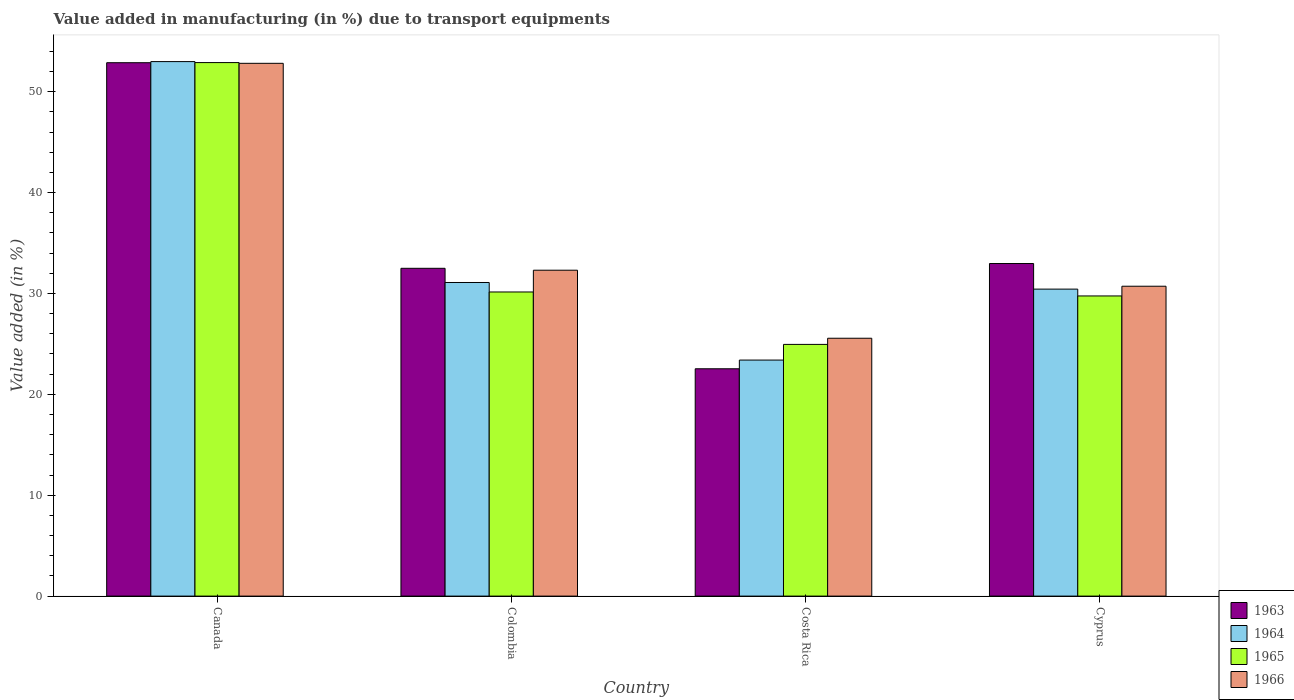How many different coloured bars are there?
Make the answer very short. 4. Are the number of bars on each tick of the X-axis equal?
Provide a succinct answer. Yes. What is the percentage of value added in manufacturing due to transport equipments in 1963 in Canada?
Give a very brief answer. 52.87. Across all countries, what is the maximum percentage of value added in manufacturing due to transport equipments in 1963?
Make the answer very short. 52.87. Across all countries, what is the minimum percentage of value added in manufacturing due to transport equipments in 1964?
Offer a very short reply. 23.4. In which country was the percentage of value added in manufacturing due to transport equipments in 1963 maximum?
Offer a terse response. Canada. In which country was the percentage of value added in manufacturing due to transport equipments in 1965 minimum?
Keep it short and to the point. Costa Rica. What is the total percentage of value added in manufacturing due to transport equipments in 1966 in the graph?
Offer a terse response. 141.39. What is the difference between the percentage of value added in manufacturing due to transport equipments in 1963 in Canada and that in Costa Rica?
Offer a terse response. 30.34. What is the difference between the percentage of value added in manufacturing due to transport equipments in 1964 in Cyprus and the percentage of value added in manufacturing due to transport equipments in 1963 in Canada?
Make the answer very short. -22.44. What is the average percentage of value added in manufacturing due to transport equipments in 1965 per country?
Offer a terse response. 34.43. What is the difference between the percentage of value added in manufacturing due to transport equipments of/in 1964 and percentage of value added in manufacturing due to transport equipments of/in 1966 in Cyprus?
Ensure brevity in your answer.  -0.29. What is the ratio of the percentage of value added in manufacturing due to transport equipments in 1963 in Colombia to that in Costa Rica?
Your answer should be very brief. 1.44. Is the percentage of value added in manufacturing due to transport equipments in 1966 in Canada less than that in Colombia?
Make the answer very short. No. Is the difference between the percentage of value added in manufacturing due to transport equipments in 1964 in Canada and Costa Rica greater than the difference between the percentage of value added in manufacturing due to transport equipments in 1966 in Canada and Costa Rica?
Give a very brief answer. Yes. What is the difference between the highest and the second highest percentage of value added in manufacturing due to transport equipments in 1966?
Keep it short and to the point. -20.51. What is the difference between the highest and the lowest percentage of value added in manufacturing due to transport equipments in 1964?
Give a very brief answer. 29.59. Is the sum of the percentage of value added in manufacturing due to transport equipments in 1963 in Canada and Costa Rica greater than the maximum percentage of value added in manufacturing due to transport equipments in 1964 across all countries?
Ensure brevity in your answer.  Yes. Is it the case that in every country, the sum of the percentage of value added in manufacturing due to transport equipments in 1963 and percentage of value added in manufacturing due to transport equipments in 1965 is greater than the sum of percentage of value added in manufacturing due to transport equipments in 1966 and percentage of value added in manufacturing due to transport equipments in 1964?
Your answer should be compact. No. What does the 2nd bar from the left in Canada represents?
Your response must be concise. 1964. What does the 1st bar from the right in Cyprus represents?
Offer a terse response. 1966. Are all the bars in the graph horizontal?
Give a very brief answer. No. What is the difference between two consecutive major ticks on the Y-axis?
Ensure brevity in your answer.  10. Are the values on the major ticks of Y-axis written in scientific E-notation?
Provide a succinct answer. No. Does the graph contain grids?
Provide a short and direct response. No. What is the title of the graph?
Your response must be concise. Value added in manufacturing (in %) due to transport equipments. What is the label or title of the Y-axis?
Offer a terse response. Value added (in %). What is the Value added (in %) of 1963 in Canada?
Provide a succinct answer. 52.87. What is the Value added (in %) of 1964 in Canada?
Ensure brevity in your answer.  52.98. What is the Value added (in %) of 1965 in Canada?
Your answer should be compact. 52.89. What is the Value added (in %) in 1966 in Canada?
Your response must be concise. 52.81. What is the Value added (in %) in 1963 in Colombia?
Provide a succinct answer. 32.49. What is the Value added (in %) of 1964 in Colombia?
Your answer should be compact. 31.09. What is the Value added (in %) in 1965 in Colombia?
Ensure brevity in your answer.  30.15. What is the Value added (in %) in 1966 in Colombia?
Your response must be concise. 32.3. What is the Value added (in %) of 1963 in Costa Rica?
Your response must be concise. 22.53. What is the Value added (in %) of 1964 in Costa Rica?
Your response must be concise. 23.4. What is the Value added (in %) of 1965 in Costa Rica?
Provide a short and direct response. 24.95. What is the Value added (in %) in 1966 in Costa Rica?
Your answer should be very brief. 25.56. What is the Value added (in %) in 1963 in Cyprus?
Your answer should be compact. 32.97. What is the Value added (in %) in 1964 in Cyprus?
Your answer should be very brief. 30.43. What is the Value added (in %) in 1965 in Cyprus?
Provide a succinct answer. 29.75. What is the Value added (in %) of 1966 in Cyprus?
Your response must be concise. 30.72. Across all countries, what is the maximum Value added (in %) of 1963?
Your answer should be compact. 52.87. Across all countries, what is the maximum Value added (in %) of 1964?
Offer a terse response. 52.98. Across all countries, what is the maximum Value added (in %) in 1965?
Your answer should be very brief. 52.89. Across all countries, what is the maximum Value added (in %) of 1966?
Your answer should be compact. 52.81. Across all countries, what is the minimum Value added (in %) in 1963?
Ensure brevity in your answer.  22.53. Across all countries, what is the minimum Value added (in %) in 1964?
Keep it short and to the point. 23.4. Across all countries, what is the minimum Value added (in %) in 1965?
Your answer should be compact. 24.95. Across all countries, what is the minimum Value added (in %) in 1966?
Ensure brevity in your answer.  25.56. What is the total Value added (in %) in 1963 in the graph?
Keep it short and to the point. 140.87. What is the total Value added (in %) in 1964 in the graph?
Make the answer very short. 137.89. What is the total Value added (in %) in 1965 in the graph?
Provide a succinct answer. 137.73. What is the total Value added (in %) of 1966 in the graph?
Offer a terse response. 141.39. What is the difference between the Value added (in %) of 1963 in Canada and that in Colombia?
Offer a very short reply. 20.38. What is the difference between the Value added (in %) in 1964 in Canada and that in Colombia?
Your answer should be very brief. 21.9. What is the difference between the Value added (in %) in 1965 in Canada and that in Colombia?
Offer a terse response. 22.74. What is the difference between the Value added (in %) of 1966 in Canada and that in Colombia?
Your answer should be compact. 20.51. What is the difference between the Value added (in %) in 1963 in Canada and that in Costa Rica?
Keep it short and to the point. 30.34. What is the difference between the Value added (in %) in 1964 in Canada and that in Costa Rica?
Provide a succinct answer. 29.59. What is the difference between the Value added (in %) in 1965 in Canada and that in Costa Rica?
Offer a very short reply. 27.93. What is the difference between the Value added (in %) of 1966 in Canada and that in Costa Rica?
Your response must be concise. 27.25. What is the difference between the Value added (in %) of 1963 in Canada and that in Cyprus?
Make the answer very short. 19.91. What is the difference between the Value added (in %) of 1964 in Canada and that in Cyprus?
Offer a very short reply. 22.55. What is the difference between the Value added (in %) of 1965 in Canada and that in Cyprus?
Ensure brevity in your answer.  23.13. What is the difference between the Value added (in %) in 1966 in Canada and that in Cyprus?
Keep it short and to the point. 22.1. What is the difference between the Value added (in %) in 1963 in Colombia and that in Costa Rica?
Keep it short and to the point. 9.96. What is the difference between the Value added (in %) in 1964 in Colombia and that in Costa Rica?
Provide a short and direct response. 7.69. What is the difference between the Value added (in %) in 1965 in Colombia and that in Costa Rica?
Offer a terse response. 5.2. What is the difference between the Value added (in %) of 1966 in Colombia and that in Costa Rica?
Your response must be concise. 6.74. What is the difference between the Value added (in %) in 1963 in Colombia and that in Cyprus?
Your answer should be very brief. -0.47. What is the difference between the Value added (in %) in 1964 in Colombia and that in Cyprus?
Your answer should be very brief. 0.66. What is the difference between the Value added (in %) of 1965 in Colombia and that in Cyprus?
Offer a very short reply. 0.39. What is the difference between the Value added (in %) of 1966 in Colombia and that in Cyprus?
Your answer should be compact. 1.59. What is the difference between the Value added (in %) of 1963 in Costa Rica and that in Cyprus?
Ensure brevity in your answer.  -10.43. What is the difference between the Value added (in %) in 1964 in Costa Rica and that in Cyprus?
Provide a short and direct response. -7.03. What is the difference between the Value added (in %) in 1965 in Costa Rica and that in Cyprus?
Keep it short and to the point. -4.8. What is the difference between the Value added (in %) of 1966 in Costa Rica and that in Cyprus?
Keep it short and to the point. -5.16. What is the difference between the Value added (in %) of 1963 in Canada and the Value added (in %) of 1964 in Colombia?
Your response must be concise. 21.79. What is the difference between the Value added (in %) in 1963 in Canada and the Value added (in %) in 1965 in Colombia?
Your response must be concise. 22.73. What is the difference between the Value added (in %) of 1963 in Canada and the Value added (in %) of 1966 in Colombia?
Provide a succinct answer. 20.57. What is the difference between the Value added (in %) of 1964 in Canada and the Value added (in %) of 1965 in Colombia?
Provide a short and direct response. 22.84. What is the difference between the Value added (in %) of 1964 in Canada and the Value added (in %) of 1966 in Colombia?
Give a very brief answer. 20.68. What is the difference between the Value added (in %) in 1965 in Canada and the Value added (in %) in 1966 in Colombia?
Keep it short and to the point. 20.58. What is the difference between the Value added (in %) of 1963 in Canada and the Value added (in %) of 1964 in Costa Rica?
Your response must be concise. 29.48. What is the difference between the Value added (in %) in 1963 in Canada and the Value added (in %) in 1965 in Costa Rica?
Provide a succinct answer. 27.92. What is the difference between the Value added (in %) of 1963 in Canada and the Value added (in %) of 1966 in Costa Rica?
Provide a short and direct response. 27.31. What is the difference between the Value added (in %) in 1964 in Canada and the Value added (in %) in 1965 in Costa Rica?
Provide a short and direct response. 28.03. What is the difference between the Value added (in %) of 1964 in Canada and the Value added (in %) of 1966 in Costa Rica?
Provide a succinct answer. 27.42. What is the difference between the Value added (in %) in 1965 in Canada and the Value added (in %) in 1966 in Costa Rica?
Provide a succinct answer. 27.33. What is the difference between the Value added (in %) of 1963 in Canada and the Value added (in %) of 1964 in Cyprus?
Make the answer very short. 22.44. What is the difference between the Value added (in %) in 1963 in Canada and the Value added (in %) in 1965 in Cyprus?
Your answer should be compact. 23.12. What is the difference between the Value added (in %) in 1963 in Canada and the Value added (in %) in 1966 in Cyprus?
Provide a short and direct response. 22.16. What is the difference between the Value added (in %) of 1964 in Canada and the Value added (in %) of 1965 in Cyprus?
Provide a short and direct response. 23.23. What is the difference between the Value added (in %) in 1964 in Canada and the Value added (in %) in 1966 in Cyprus?
Offer a terse response. 22.27. What is the difference between the Value added (in %) of 1965 in Canada and the Value added (in %) of 1966 in Cyprus?
Make the answer very short. 22.17. What is the difference between the Value added (in %) in 1963 in Colombia and the Value added (in %) in 1964 in Costa Rica?
Provide a short and direct response. 9.1. What is the difference between the Value added (in %) in 1963 in Colombia and the Value added (in %) in 1965 in Costa Rica?
Make the answer very short. 7.54. What is the difference between the Value added (in %) in 1963 in Colombia and the Value added (in %) in 1966 in Costa Rica?
Your answer should be very brief. 6.93. What is the difference between the Value added (in %) in 1964 in Colombia and the Value added (in %) in 1965 in Costa Rica?
Offer a terse response. 6.14. What is the difference between the Value added (in %) in 1964 in Colombia and the Value added (in %) in 1966 in Costa Rica?
Offer a very short reply. 5.53. What is the difference between the Value added (in %) in 1965 in Colombia and the Value added (in %) in 1966 in Costa Rica?
Keep it short and to the point. 4.59. What is the difference between the Value added (in %) in 1963 in Colombia and the Value added (in %) in 1964 in Cyprus?
Offer a very short reply. 2.06. What is the difference between the Value added (in %) of 1963 in Colombia and the Value added (in %) of 1965 in Cyprus?
Offer a very short reply. 2.74. What is the difference between the Value added (in %) of 1963 in Colombia and the Value added (in %) of 1966 in Cyprus?
Provide a short and direct response. 1.78. What is the difference between the Value added (in %) of 1964 in Colombia and the Value added (in %) of 1965 in Cyprus?
Offer a terse response. 1.33. What is the difference between the Value added (in %) in 1964 in Colombia and the Value added (in %) in 1966 in Cyprus?
Offer a terse response. 0.37. What is the difference between the Value added (in %) of 1965 in Colombia and the Value added (in %) of 1966 in Cyprus?
Your answer should be very brief. -0.57. What is the difference between the Value added (in %) in 1963 in Costa Rica and the Value added (in %) in 1964 in Cyprus?
Ensure brevity in your answer.  -7.9. What is the difference between the Value added (in %) in 1963 in Costa Rica and the Value added (in %) in 1965 in Cyprus?
Offer a very short reply. -7.22. What is the difference between the Value added (in %) of 1963 in Costa Rica and the Value added (in %) of 1966 in Cyprus?
Your answer should be compact. -8.18. What is the difference between the Value added (in %) in 1964 in Costa Rica and the Value added (in %) in 1965 in Cyprus?
Provide a succinct answer. -6.36. What is the difference between the Value added (in %) of 1964 in Costa Rica and the Value added (in %) of 1966 in Cyprus?
Offer a very short reply. -7.32. What is the difference between the Value added (in %) of 1965 in Costa Rica and the Value added (in %) of 1966 in Cyprus?
Keep it short and to the point. -5.77. What is the average Value added (in %) of 1963 per country?
Keep it short and to the point. 35.22. What is the average Value added (in %) of 1964 per country?
Give a very brief answer. 34.47. What is the average Value added (in %) in 1965 per country?
Give a very brief answer. 34.43. What is the average Value added (in %) of 1966 per country?
Offer a very short reply. 35.35. What is the difference between the Value added (in %) in 1963 and Value added (in %) in 1964 in Canada?
Make the answer very short. -0.11. What is the difference between the Value added (in %) in 1963 and Value added (in %) in 1965 in Canada?
Your response must be concise. -0.01. What is the difference between the Value added (in %) in 1963 and Value added (in %) in 1966 in Canada?
Your answer should be compact. 0.06. What is the difference between the Value added (in %) of 1964 and Value added (in %) of 1965 in Canada?
Your answer should be compact. 0.1. What is the difference between the Value added (in %) in 1964 and Value added (in %) in 1966 in Canada?
Offer a terse response. 0.17. What is the difference between the Value added (in %) of 1965 and Value added (in %) of 1966 in Canada?
Provide a short and direct response. 0.07. What is the difference between the Value added (in %) in 1963 and Value added (in %) in 1964 in Colombia?
Offer a terse response. 1.41. What is the difference between the Value added (in %) of 1963 and Value added (in %) of 1965 in Colombia?
Your answer should be compact. 2.35. What is the difference between the Value added (in %) of 1963 and Value added (in %) of 1966 in Colombia?
Your answer should be compact. 0.19. What is the difference between the Value added (in %) in 1964 and Value added (in %) in 1965 in Colombia?
Offer a very short reply. 0.94. What is the difference between the Value added (in %) of 1964 and Value added (in %) of 1966 in Colombia?
Ensure brevity in your answer.  -1.22. What is the difference between the Value added (in %) in 1965 and Value added (in %) in 1966 in Colombia?
Ensure brevity in your answer.  -2.16. What is the difference between the Value added (in %) of 1963 and Value added (in %) of 1964 in Costa Rica?
Offer a very short reply. -0.86. What is the difference between the Value added (in %) of 1963 and Value added (in %) of 1965 in Costa Rica?
Offer a terse response. -2.42. What is the difference between the Value added (in %) of 1963 and Value added (in %) of 1966 in Costa Rica?
Make the answer very short. -3.03. What is the difference between the Value added (in %) of 1964 and Value added (in %) of 1965 in Costa Rica?
Make the answer very short. -1.55. What is the difference between the Value added (in %) of 1964 and Value added (in %) of 1966 in Costa Rica?
Offer a very short reply. -2.16. What is the difference between the Value added (in %) of 1965 and Value added (in %) of 1966 in Costa Rica?
Give a very brief answer. -0.61. What is the difference between the Value added (in %) in 1963 and Value added (in %) in 1964 in Cyprus?
Your response must be concise. 2.54. What is the difference between the Value added (in %) in 1963 and Value added (in %) in 1965 in Cyprus?
Offer a very short reply. 3.21. What is the difference between the Value added (in %) in 1963 and Value added (in %) in 1966 in Cyprus?
Offer a very short reply. 2.25. What is the difference between the Value added (in %) of 1964 and Value added (in %) of 1965 in Cyprus?
Offer a terse response. 0.68. What is the difference between the Value added (in %) of 1964 and Value added (in %) of 1966 in Cyprus?
Keep it short and to the point. -0.29. What is the difference between the Value added (in %) in 1965 and Value added (in %) in 1966 in Cyprus?
Ensure brevity in your answer.  -0.96. What is the ratio of the Value added (in %) in 1963 in Canada to that in Colombia?
Keep it short and to the point. 1.63. What is the ratio of the Value added (in %) in 1964 in Canada to that in Colombia?
Offer a very short reply. 1.7. What is the ratio of the Value added (in %) in 1965 in Canada to that in Colombia?
Offer a very short reply. 1.75. What is the ratio of the Value added (in %) of 1966 in Canada to that in Colombia?
Provide a succinct answer. 1.63. What is the ratio of the Value added (in %) in 1963 in Canada to that in Costa Rica?
Your response must be concise. 2.35. What is the ratio of the Value added (in %) of 1964 in Canada to that in Costa Rica?
Offer a very short reply. 2.26. What is the ratio of the Value added (in %) of 1965 in Canada to that in Costa Rica?
Make the answer very short. 2.12. What is the ratio of the Value added (in %) of 1966 in Canada to that in Costa Rica?
Your response must be concise. 2.07. What is the ratio of the Value added (in %) of 1963 in Canada to that in Cyprus?
Provide a succinct answer. 1.6. What is the ratio of the Value added (in %) in 1964 in Canada to that in Cyprus?
Ensure brevity in your answer.  1.74. What is the ratio of the Value added (in %) in 1965 in Canada to that in Cyprus?
Provide a succinct answer. 1.78. What is the ratio of the Value added (in %) of 1966 in Canada to that in Cyprus?
Make the answer very short. 1.72. What is the ratio of the Value added (in %) of 1963 in Colombia to that in Costa Rica?
Offer a terse response. 1.44. What is the ratio of the Value added (in %) in 1964 in Colombia to that in Costa Rica?
Offer a terse response. 1.33. What is the ratio of the Value added (in %) in 1965 in Colombia to that in Costa Rica?
Keep it short and to the point. 1.21. What is the ratio of the Value added (in %) in 1966 in Colombia to that in Costa Rica?
Keep it short and to the point. 1.26. What is the ratio of the Value added (in %) in 1963 in Colombia to that in Cyprus?
Ensure brevity in your answer.  0.99. What is the ratio of the Value added (in %) in 1964 in Colombia to that in Cyprus?
Your response must be concise. 1.02. What is the ratio of the Value added (in %) in 1965 in Colombia to that in Cyprus?
Keep it short and to the point. 1.01. What is the ratio of the Value added (in %) in 1966 in Colombia to that in Cyprus?
Your response must be concise. 1.05. What is the ratio of the Value added (in %) in 1963 in Costa Rica to that in Cyprus?
Provide a short and direct response. 0.68. What is the ratio of the Value added (in %) of 1964 in Costa Rica to that in Cyprus?
Ensure brevity in your answer.  0.77. What is the ratio of the Value added (in %) of 1965 in Costa Rica to that in Cyprus?
Provide a succinct answer. 0.84. What is the ratio of the Value added (in %) in 1966 in Costa Rica to that in Cyprus?
Keep it short and to the point. 0.83. What is the difference between the highest and the second highest Value added (in %) in 1963?
Your response must be concise. 19.91. What is the difference between the highest and the second highest Value added (in %) in 1964?
Keep it short and to the point. 21.9. What is the difference between the highest and the second highest Value added (in %) of 1965?
Provide a short and direct response. 22.74. What is the difference between the highest and the second highest Value added (in %) in 1966?
Your answer should be compact. 20.51. What is the difference between the highest and the lowest Value added (in %) of 1963?
Offer a terse response. 30.34. What is the difference between the highest and the lowest Value added (in %) in 1964?
Your answer should be compact. 29.59. What is the difference between the highest and the lowest Value added (in %) of 1965?
Provide a succinct answer. 27.93. What is the difference between the highest and the lowest Value added (in %) in 1966?
Keep it short and to the point. 27.25. 